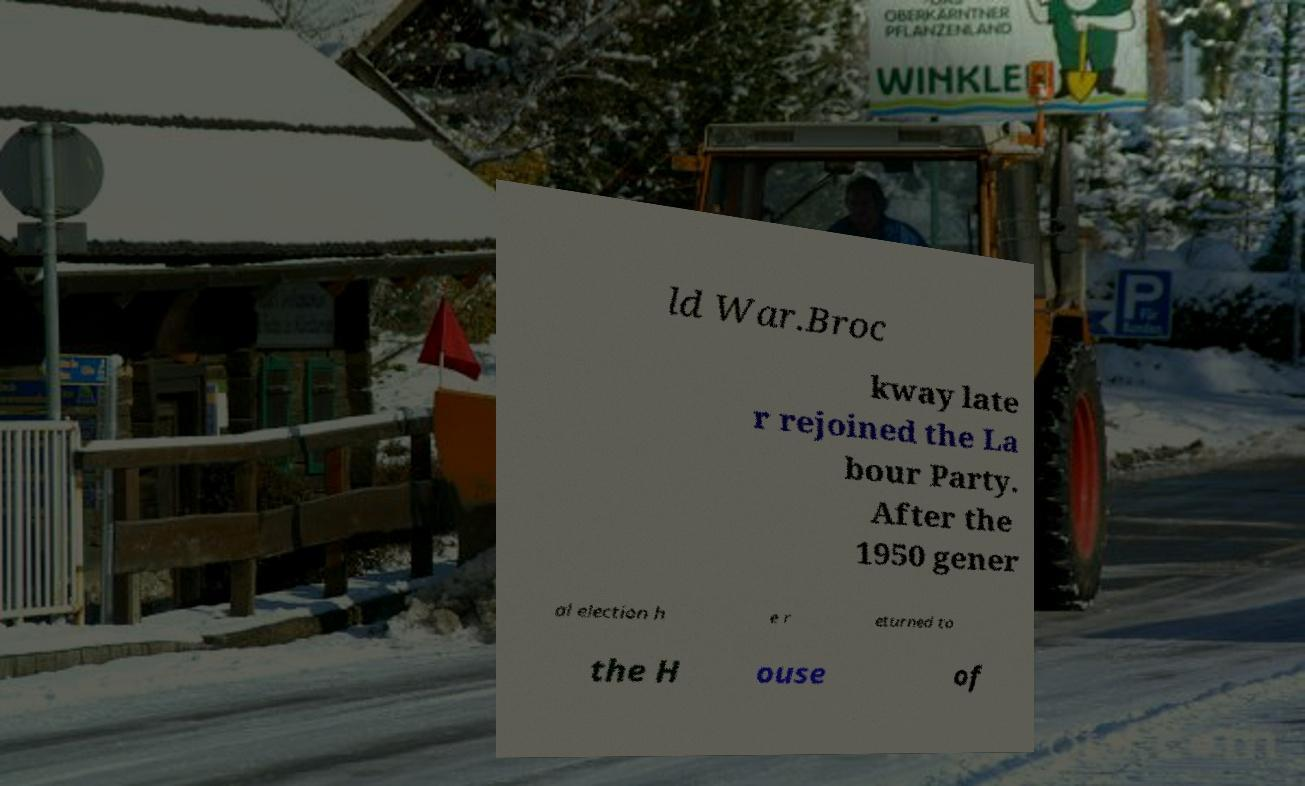There's text embedded in this image that I need extracted. Can you transcribe it verbatim? ld War.Broc kway late r rejoined the La bour Party. After the 1950 gener al election h e r eturned to the H ouse of 